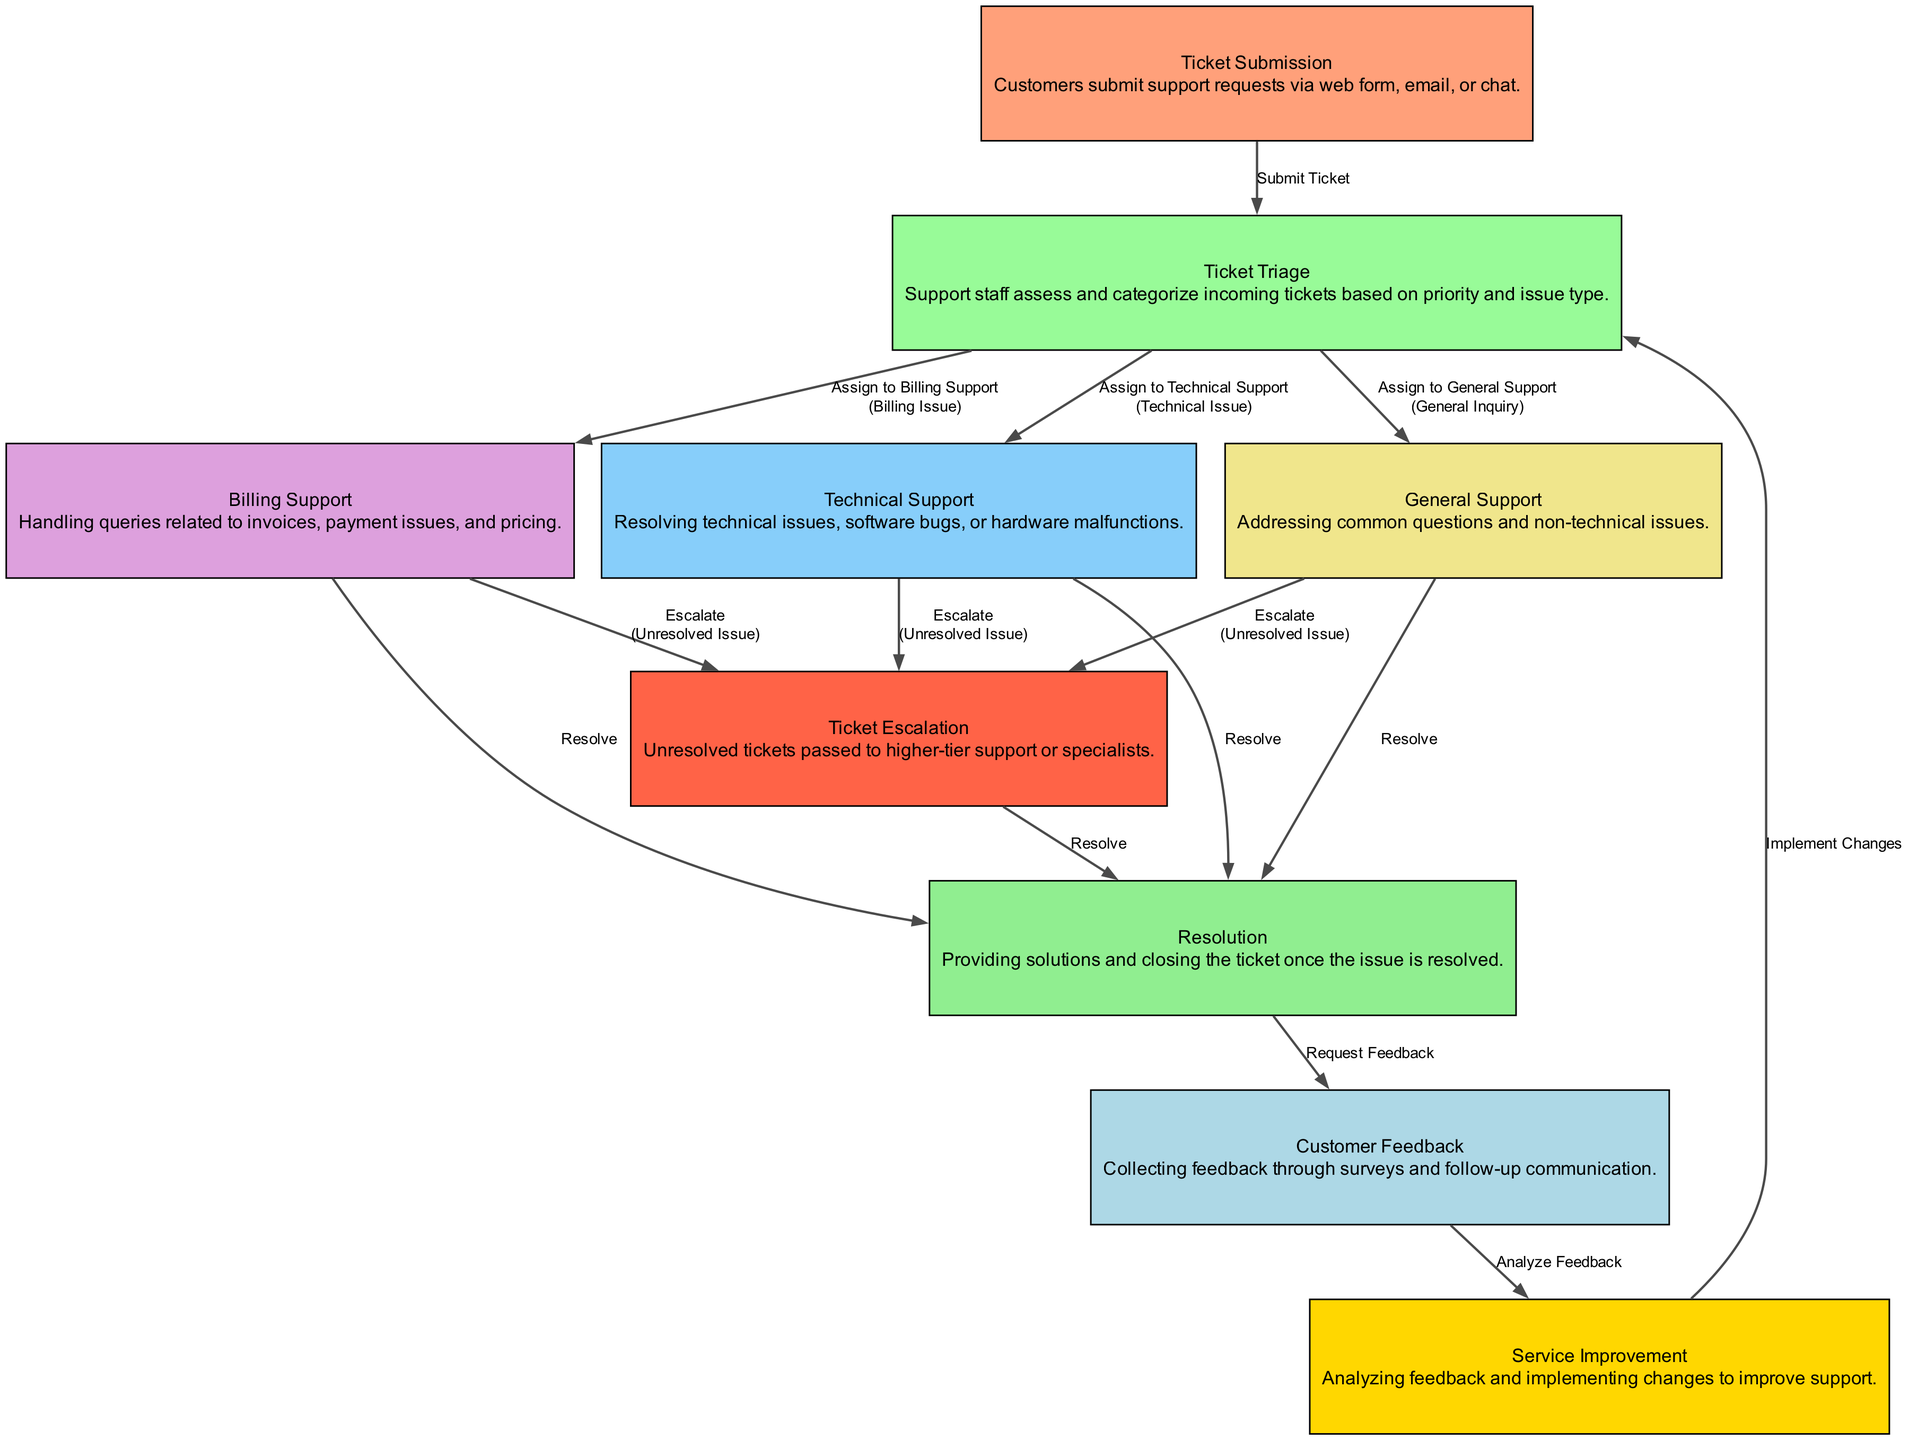What is the first step in the customer support workflow? The first step in the workflow is the "Ticket Submission." This is where customers submit their support requests via various channels such as web forms, email, or chat.
Answer: Ticket Submission How many support types are assigned after ticket triage? After the Ticket Triage process, there are three support types assigned: Technical Support, Billing Support, and General Support. Each type corresponds to different issue categorizations.
Answer: Three What happens if an issue remains unresolved in the technical support process? If an issue remains unresolved in the Technical Support process, it is escalated to higher-tier support or specialists in the Ticket Escalation step. This ensures more experienced personnel address the ongoing issue.
Answer: Escalate What is the final step after resolution? The final step after Resolution is to collect Customer Feedback. This step involves requesting feedback from customers to assess their satisfaction and gather data for service improvements.
Answer: Customer Feedback How does customer feedback contribute to the workflow? Customer Feedback contributes to the workflow by being analyzed for Service Improvement. This leads to changes being implemented back in the Ticket Triage, ensuring continual service enhancement based on customer insights.
Answer: Service Improvement What are the conditions for assigning support types during ticket triage? The conditions for assigning support types during Ticket Triage are based on the nature of the issue: Technical Issue, Billing Issue, or General Inquiry, determining which support team will handle the ticket.
Answer: Technical Issue, Billing Issue, General Inquiry How many edges connect the ticket submission to the ticket triage? There is one edge connecting the Ticket Submission to the Ticket Triage, labeled "Submit Ticket." This edge represents the transition of the ticket into the next workflow phase.
Answer: One What type of support deals with payment issues? The type of support that deals with payment issues is "Billing Support." This support team is responsible for addressing queries related to invoices, payment problems, and pricing concerns.
Answer: Billing Support 